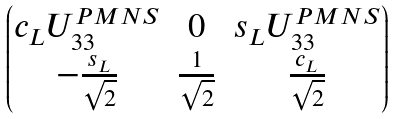Convert formula to latex. <formula><loc_0><loc_0><loc_500><loc_500>\begin{pmatrix} c _ { L } U ^ { P M N S } _ { 3 3 } & 0 & s _ { L } U ^ { P M N S } _ { 3 3 } \\ - \frac { s _ { L } } { \sqrt { 2 } } & \frac { 1 } { \sqrt { 2 } } & \frac { c _ { L } } { \sqrt { 2 } } \end{pmatrix}</formula> 